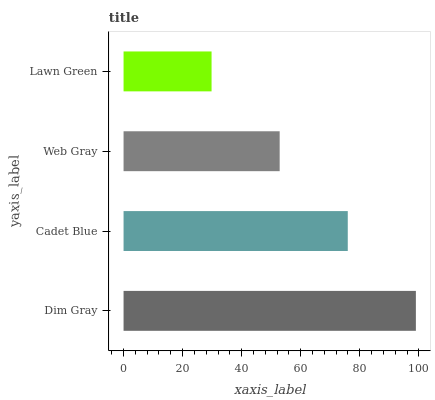Is Lawn Green the minimum?
Answer yes or no. Yes. Is Dim Gray the maximum?
Answer yes or no. Yes. Is Cadet Blue the minimum?
Answer yes or no. No. Is Cadet Blue the maximum?
Answer yes or no. No. Is Dim Gray greater than Cadet Blue?
Answer yes or no. Yes. Is Cadet Blue less than Dim Gray?
Answer yes or no. Yes. Is Cadet Blue greater than Dim Gray?
Answer yes or no. No. Is Dim Gray less than Cadet Blue?
Answer yes or no. No. Is Cadet Blue the high median?
Answer yes or no. Yes. Is Web Gray the low median?
Answer yes or no. Yes. Is Web Gray the high median?
Answer yes or no. No. Is Dim Gray the low median?
Answer yes or no. No. 